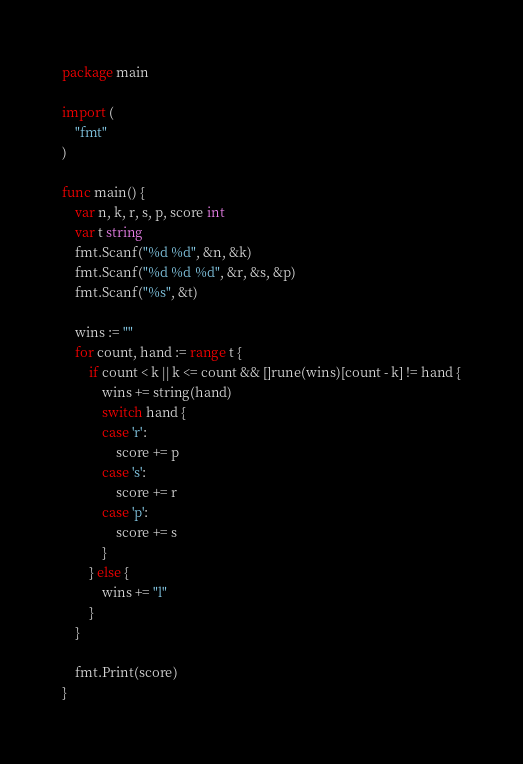Convert code to text. <code><loc_0><loc_0><loc_500><loc_500><_Go_>package main

import (
	"fmt"
)

func main() {
	var n, k, r, s, p, score int
	var t string
	fmt.Scanf("%d %d", &n, &k)
	fmt.Scanf("%d %d %d", &r, &s, &p)
	fmt.Scanf("%s", &t)

	wins := ""
	for count, hand := range t {
		if count < k || k <= count && []rune(wins)[count - k] != hand {
			wins += string(hand)
			switch hand {
			case 'r':
				score += p
			case 's':
				score += r
			case 'p':
				score += s
			}
		} else {
			wins += "l"
		}
	}

	fmt.Print(score)
}
</code> 